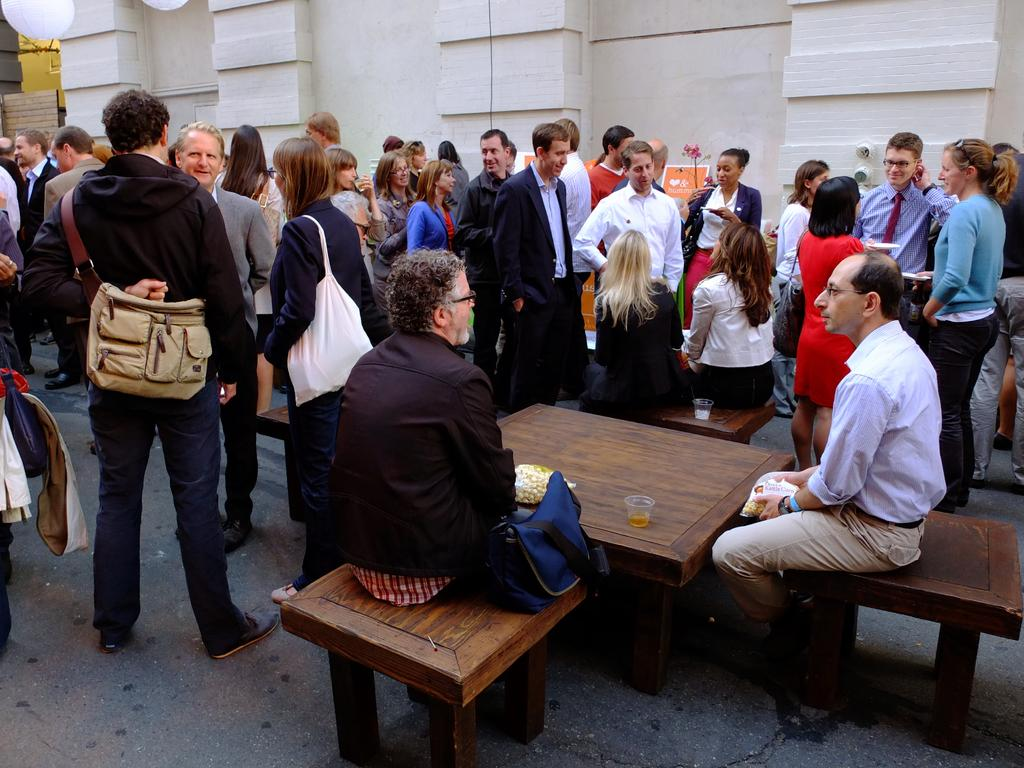What are the people in the image doing? There is a group of people standing, and some persons are sitting on chairs. What can be seen on the table in the image? There is a glass on the table. What is present in the background of the image? There is a wall in the image. Is there any person carrying an accessory in the image? Yes, one person is wearing a bag. What type of smile can be seen on the person's face in the image? There is no information about the person's facial expression in the image, so we cannot determine if there is a smile or not. 